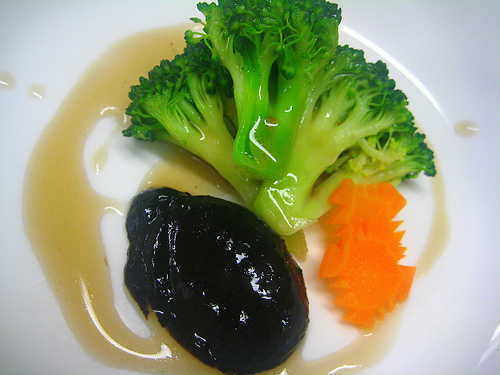Can you describe the texture of the black item on the plate? The black item on the plate has a glossy, smooth surface which suggests it may have a firm, possibly gelatinous texture. It is likely to be a savory component, such as a reduction or a dense vegetable puree. What might be the taste profile of the dark sauce surrounding the food? The dark sauce has a smooth consistency with a sheen that suggests it may be rich in flavor, possibly umami, with a savory taste that could complement the main ingredient's texture and natural flavors. 